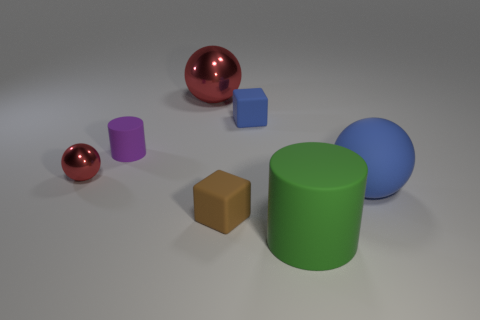The purple matte object is what size?
Ensure brevity in your answer.  Small. There is a tiny object that is on the right side of the matte block that is in front of the shiny thing that is in front of the large red thing; what is it made of?
Your response must be concise. Rubber. The tiny cylinder that is the same material as the big blue object is what color?
Offer a terse response. Purple. How many big spheres are in front of the red thing that is in front of the red metal sphere on the right side of the purple object?
Your answer should be very brief. 1. There is a thing that is the same color as the tiny sphere; what material is it?
Make the answer very short. Metal. Are there any other things that have the same shape as the brown matte object?
Ensure brevity in your answer.  Yes. How many objects are either shiny things in front of the big red metallic ball or small metallic things?
Provide a succinct answer. 1. There is a big thing that is in front of the big blue matte sphere; is it the same color as the small shiny thing?
Keep it short and to the point. No. There is a shiny object that is on the left side of the small purple matte cylinder that is left of the green rubber cylinder; what is its shape?
Provide a short and direct response. Sphere. Are there fewer big blue things left of the blue ball than large metal balls that are right of the tiny brown cube?
Your answer should be very brief. No. 